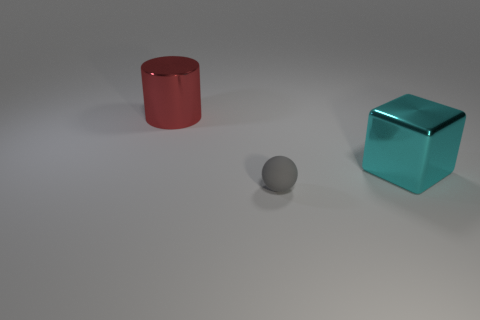Add 1 big blue metallic things. How many objects exist? 4 Subtract all balls. How many objects are left? 2 Subtract 1 cubes. How many cubes are left? 0 Subtract all small gray spheres. Subtract all blocks. How many objects are left? 1 Add 1 large cyan metallic objects. How many large cyan metallic objects are left? 2 Add 1 big cyan metal things. How many big cyan metal things exist? 2 Subtract 0 cyan spheres. How many objects are left? 3 Subtract all red blocks. Subtract all red cylinders. How many blocks are left? 1 